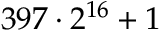Convert formula to latex. <formula><loc_0><loc_0><loc_500><loc_500>3 9 7 \cdot 2 ^ { 1 6 } + 1</formula> 